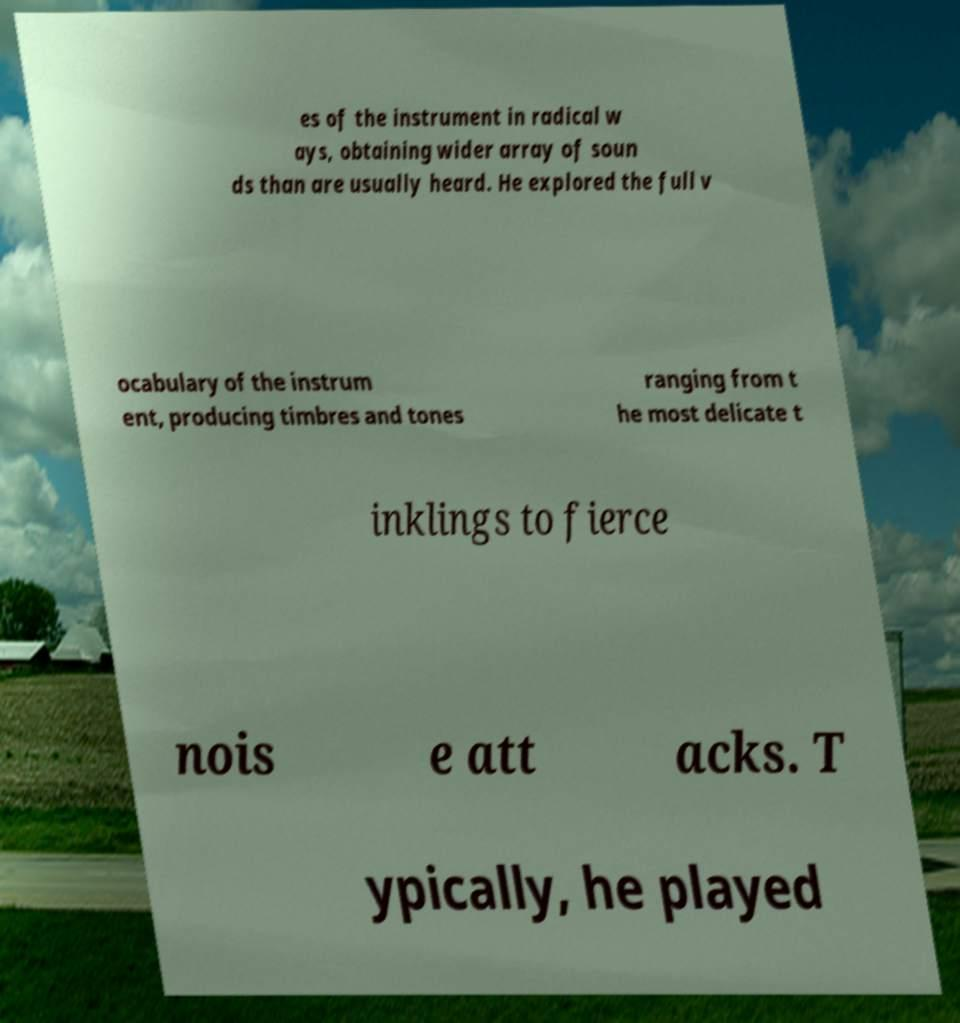Can you accurately transcribe the text from the provided image for me? es of the instrument in radical w ays, obtaining wider array of soun ds than are usually heard. He explored the full v ocabulary of the instrum ent, producing timbres and tones ranging from t he most delicate t inklings to fierce nois e att acks. T ypically, he played 